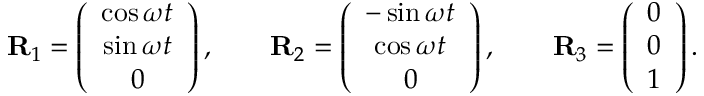Convert formula to latex. <formula><loc_0><loc_0><loc_500><loc_500>\begin{array} { r } { { R } _ { 1 } = \left ( \begin{array} { c } { \cos \omega t } \\ { \sin \omega t } \\ { 0 } \end{array} \right ) , \quad { R } _ { 2 } = \left ( \begin{array} { c } { - \sin \omega t } \\ { \cos \omega t } \\ { 0 } \end{array} \right ) , \quad { R } _ { 3 } = \left ( \begin{array} { c } { 0 } \\ { 0 } \\ { 1 } \end{array} \right ) . } \end{array}</formula> 